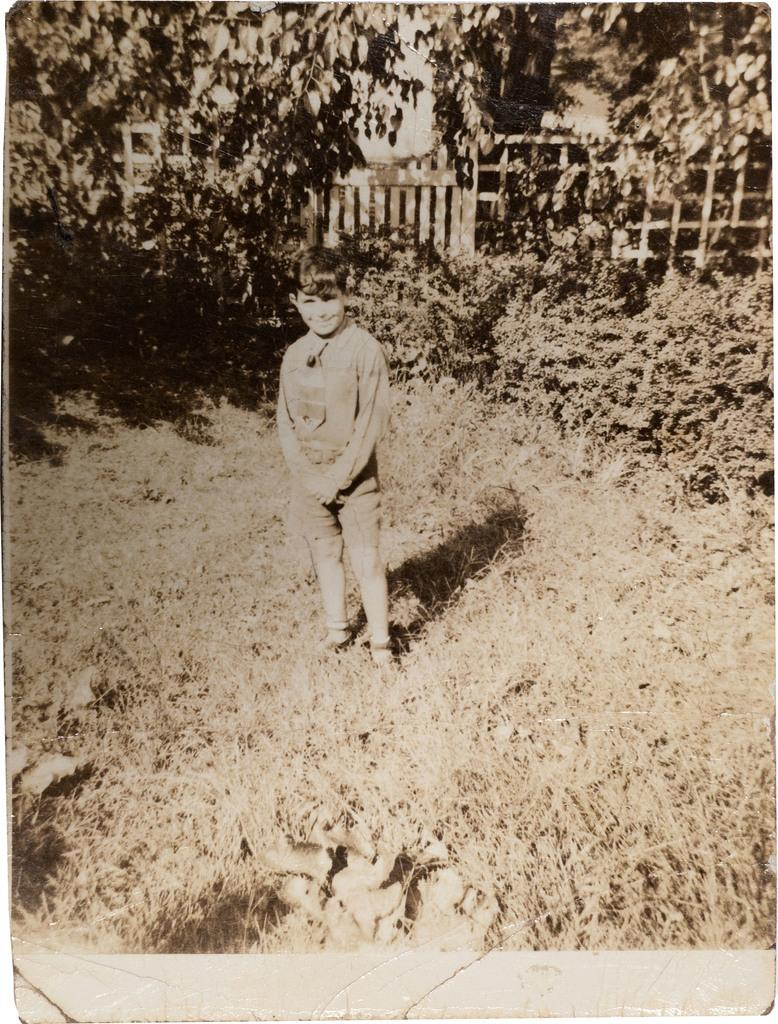What is the main subject of the picture? The main subject of the picture is a kid standing. What type of surface is the kid standing on? There is grass at the bottom of the image, so the kid is standing on grass. What can be seen in the background of the image? There are trees in the background of the image. What effect does the sun have on the kid in the image? There is no sun visible in the image, so it is not possible to determine any effect it might have on the kid. 